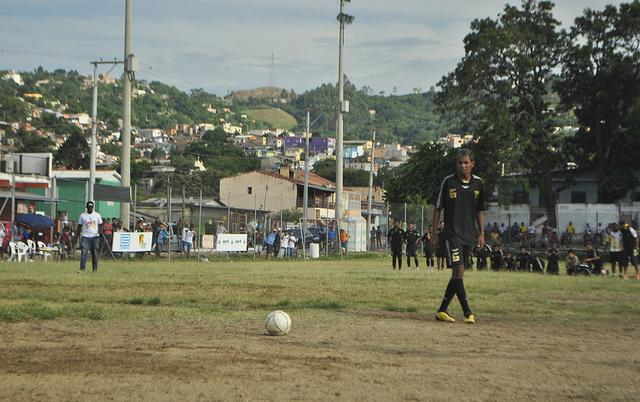What international tournament takes place every 4 years where this sport is played? world cup 